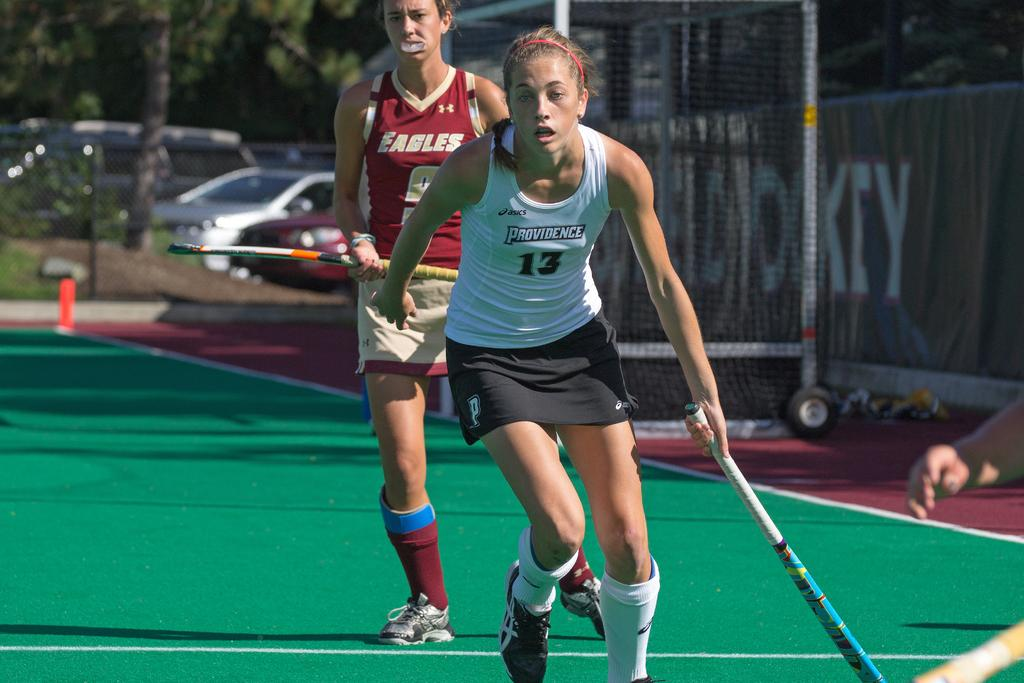Provide a one-sentence caption for the provided image. A girl wearing a red top with Eagles on it watches her opponent who is wearing a white top with Providence on it in a hockey match. 